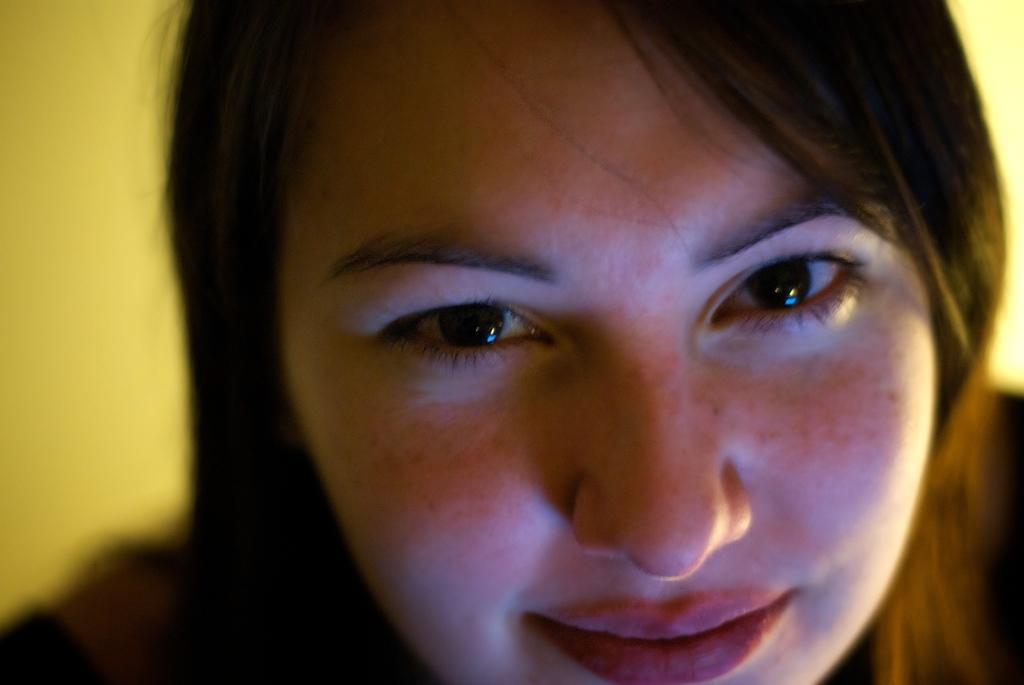In one or two sentences, can you explain what this image depicts? In this image we can see a woman. There is a yellow color background. 